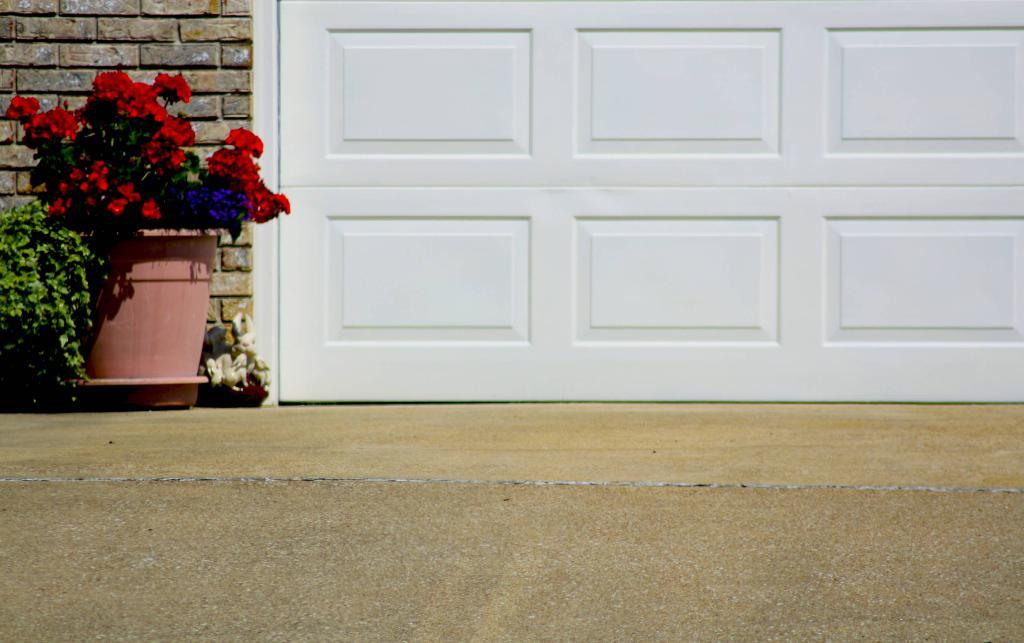What type of plant is visible in the image? There is a plant in the image. What can be seen growing on the plant? There are flowers in the image. What colors are the flowers? The flowers are in purple and red colors. What color is the plant itself? The plant is in green color. What is visible in the background of the image? There is a wooden door in the background of the image. What color is the wooden door? The wooden door is in white color. How does the plant maintain its balance during the war in the image? There is no war present in the image, and the plant does not need to maintain its balance. 